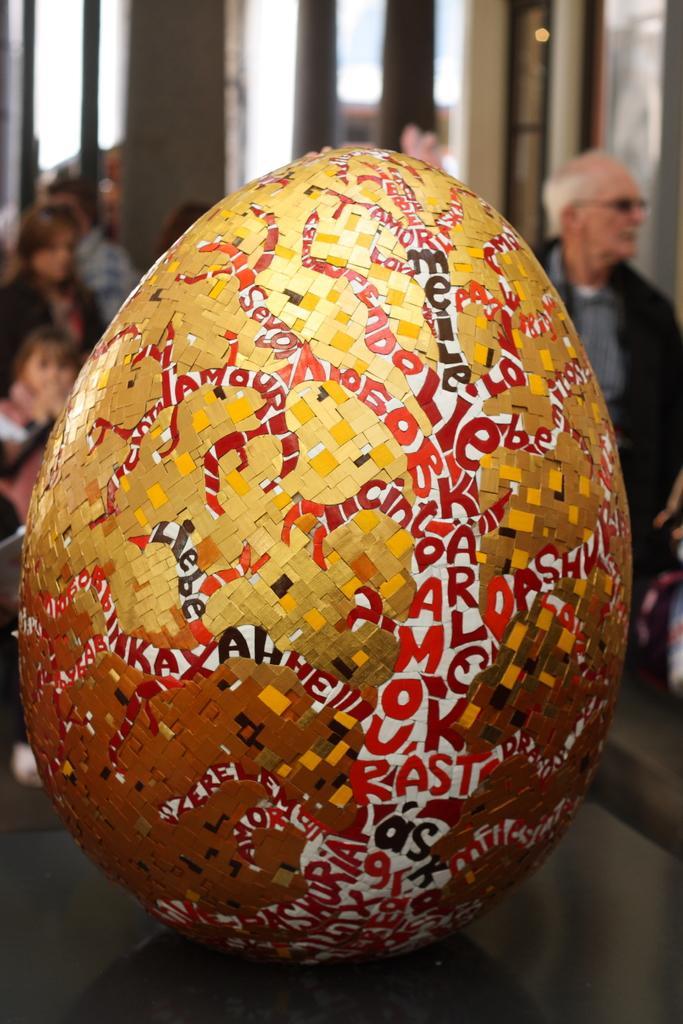Describe this image in one or two sentences. In this image we can see an object in the shape of an oval. On the object we can see some text. Behind the object there are few persons. The background of the image is blurred. 